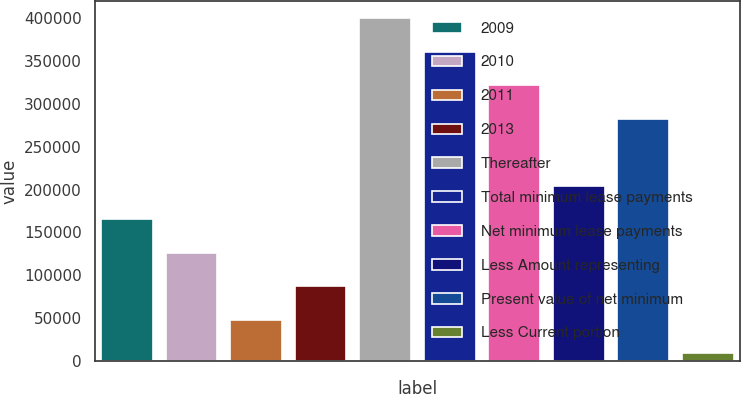Convert chart. <chart><loc_0><loc_0><loc_500><loc_500><bar_chart><fcel>2009<fcel>2010<fcel>2011<fcel>2013<fcel>Thereafter<fcel>Total minimum lease payments<fcel>Net minimum lease payments<fcel>Less Amount representing<fcel>Present value of net minimum<fcel>Less Current portion<nl><fcel>165537<fcel>126460<fcel>48306.1<fcel>87383.2<fcel>400000<fcel>360923<fcel>321846<fcel>204614<fcel>282769<fcel>9229<nl></chart> 